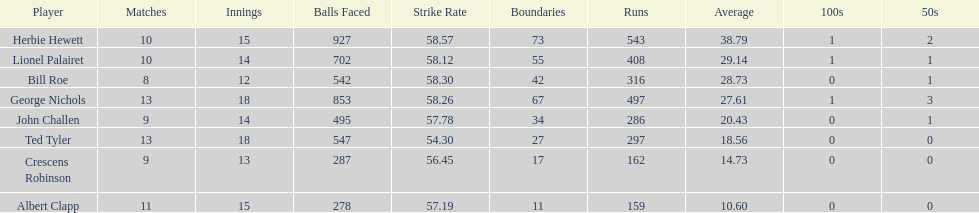How many runs did ted tyler have? 297. 